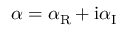Convert formula to latex. <formula><loc_0><loc_0><loc_500><loc_500>\alpha = \alpha _ { R } + i \alpha _ { I }</formula> 